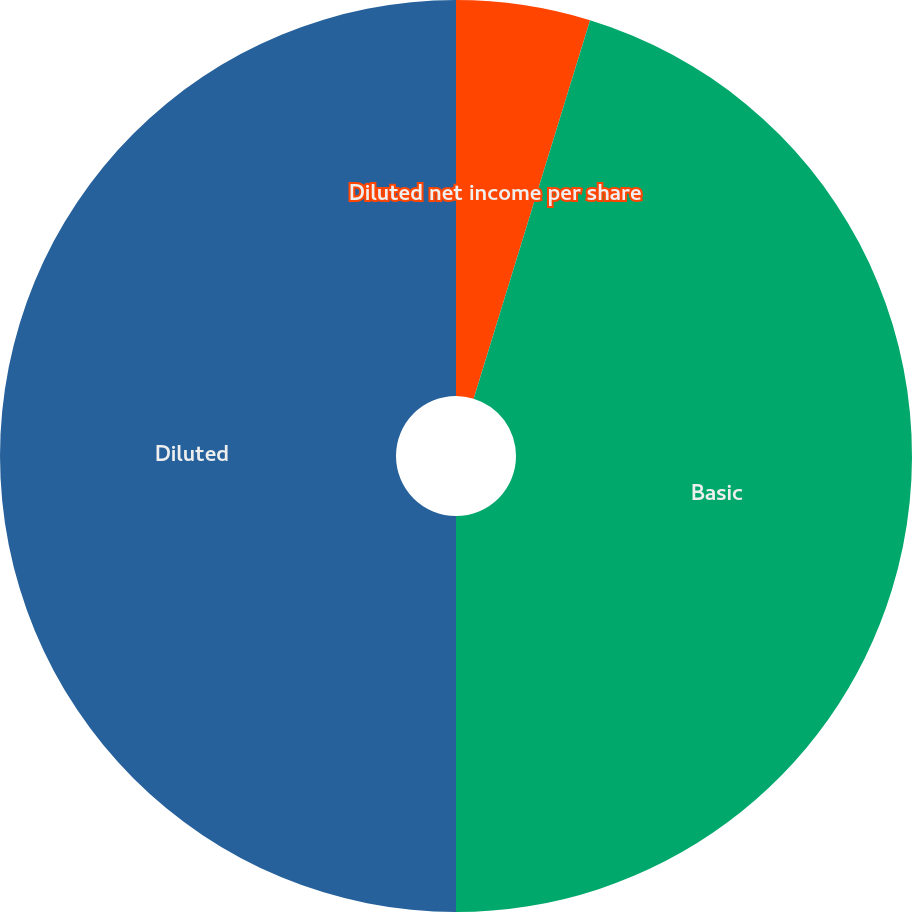<chart> <loc_0><loc_0><loc_500><loc_500><pie_chart><fcel>Income from continuing<fcel>Diluted net income per share<fcel>Basic<fcel>Diluted<nl><fcel>0.0%<fcel>4.75%<fcel>45.25%<fcel>50.0%<nl></chart> 